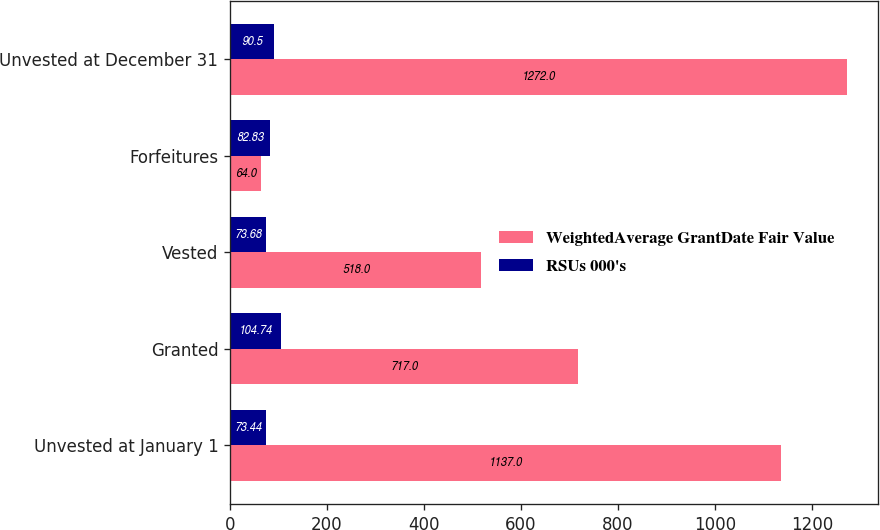Convert chart to OTSL. <chart><loc_0><loc_0><loc_500><loc_500><stacked_bar_chart><ecel><fcel>Unvested at January 1<fcel>Granted<fcel>Vested<fcel>Forfeitures<fcel>Unvested at December 31<nl><fcel>WeightedAverage GrantDate Fair Value<fcel>1137<fcel>717<fcel>518<fcel>64<fcel>1272<nl><fcel>RSUs 000's<fcel>73.44<fcel>104.74<fcel>73.68<fcel>82.83<fcel>90.5<nl></chart> 